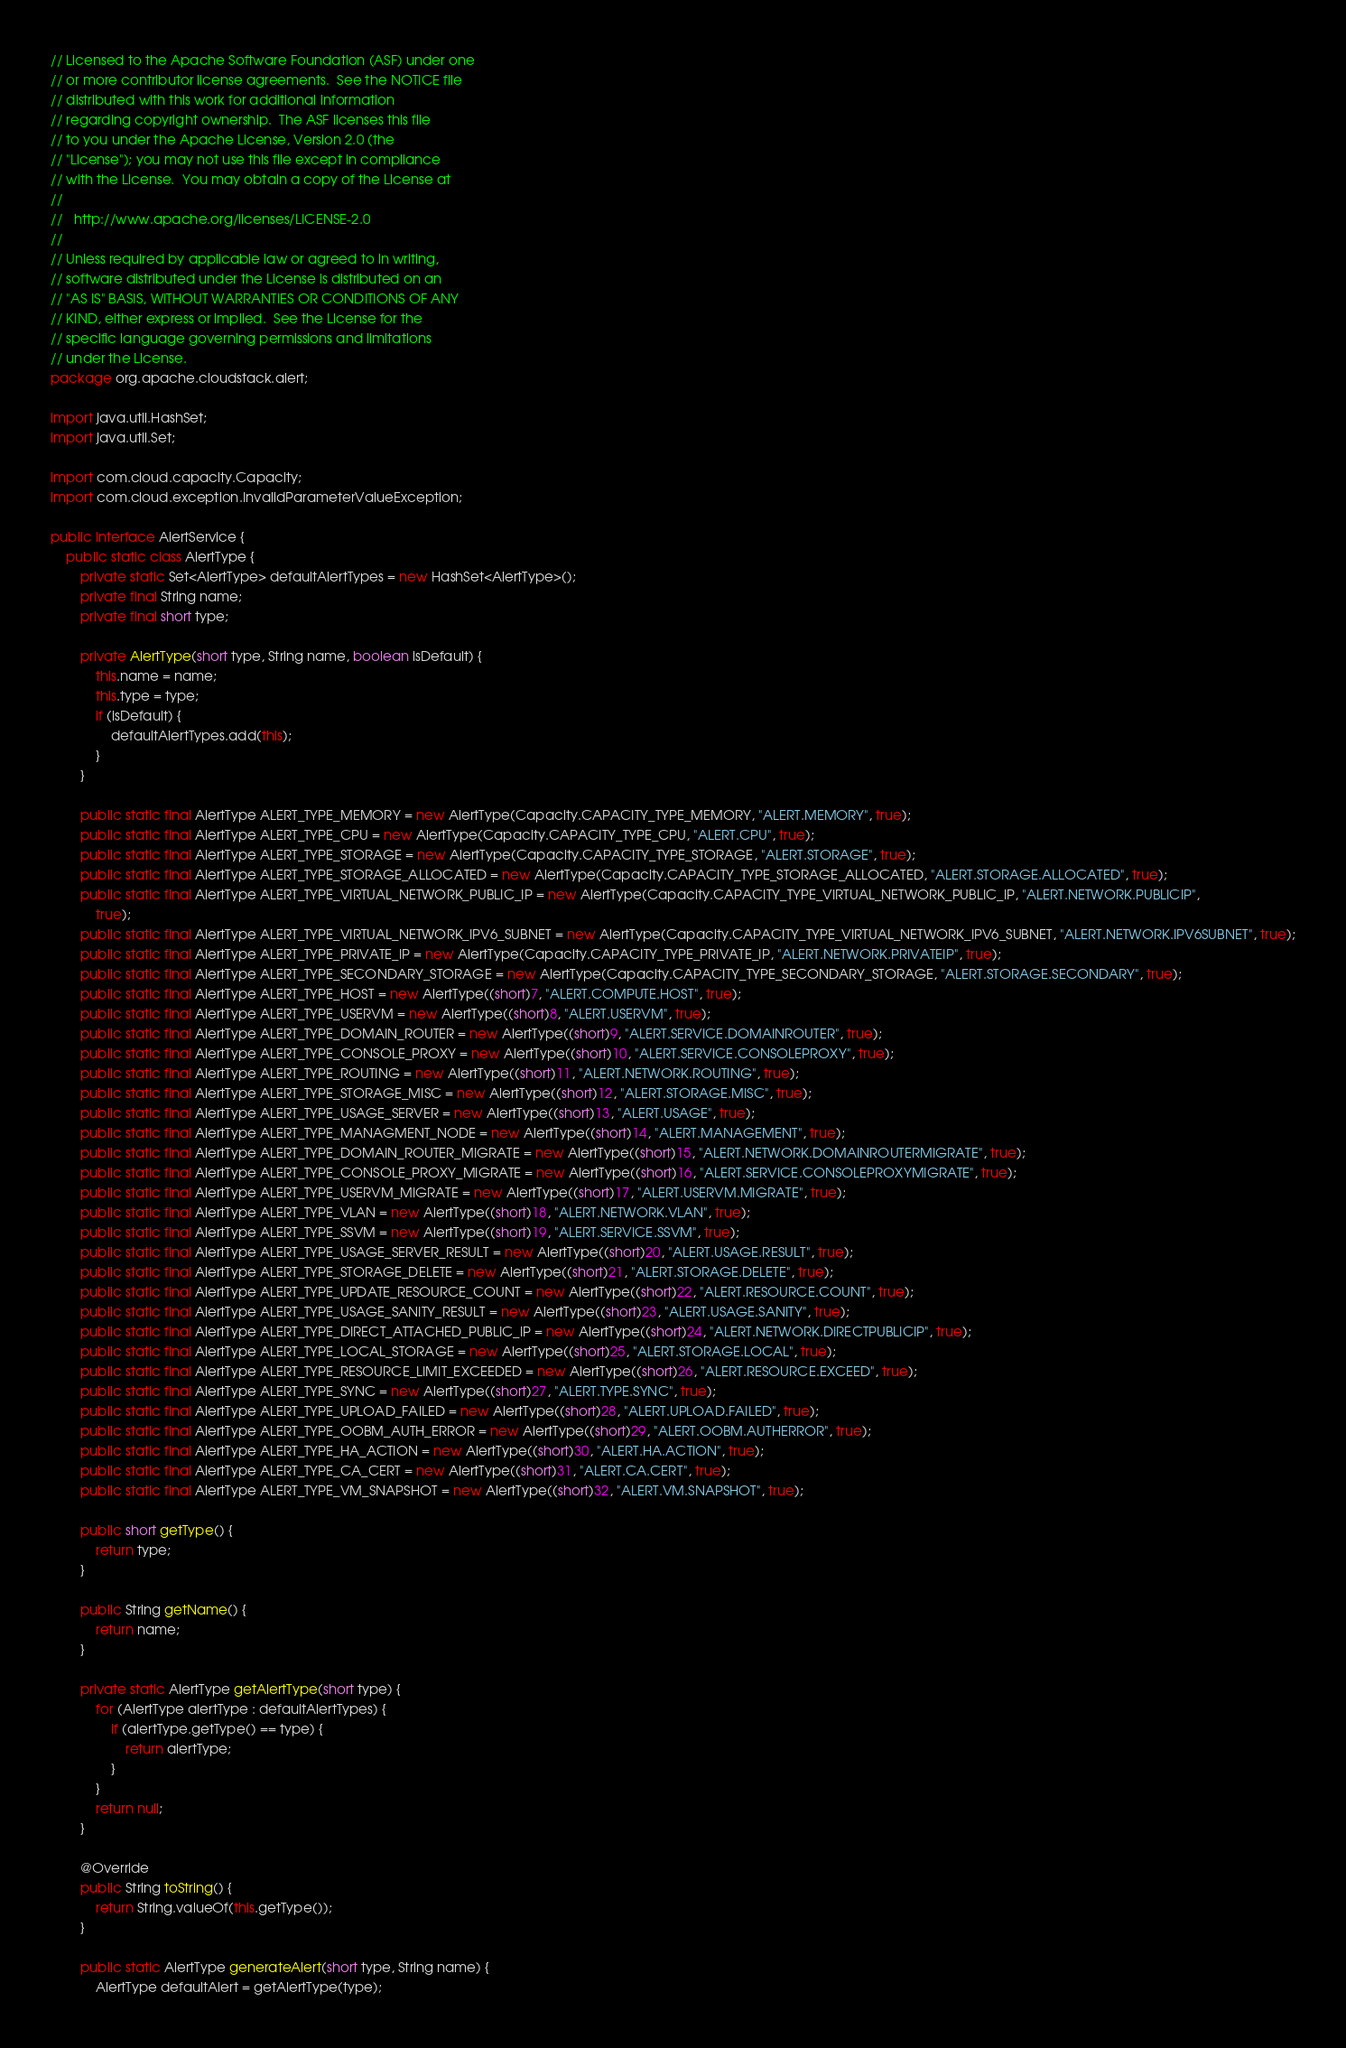Convert code to text. <code><loc_0><loc_0><loc_500><loc_500><_Java_>// Licensed to the Apache Software Foundation (ASF) under one
// or more contributor license agreements.  See the NOTICE file
// distributed with this work for additional information
// regarding copyright ownership.  The ASF licenses this file
// to you under the Apache License, Version 2.0 (the
// "License"); you may not use this file except in compliance
// with the License.  You may obtain a copy of the License at
//
//   http://www.apache.org/licenses/LICENSE-2.0
//
// Unless required by applicable law or agreed to in writing,
// software distributed under the License is distributed on an
// "AS IS" BASIS, WITHOUT WARRANTIES OR CONDITIONS OF ANY
// KIND, either express or implied.  See the License for the
// specific language governing permissions and limitations
// under the License.
package org.apache.cloudstack.alert;

import java.util.HashSet;
import java.util.Set;

import com.cloud.capacity.Capacity;
import com.cloud.exception.InvalidParameterValueException;

public interface AlertService {
    public static class AlertType {
        private static Set<AlertType> defaultAlertTypes = new HashSet<AlertType>();
        private final String name;
        private final short type;

        private AlertType(short type, String name, boolean isDefault) {
            this.name = name;
            this.type = type;
            if (isDefault) {
                defaultAlertTypes.add(this);
            }
        }

        public static final AlertType ALERT_TYPE_MEMORY = new AlertType(Capacity.CAPACITY_TYPE_MEMORY, "ALERT.MEMORY", true);
        public static final AlertType ALERT_TYPE_CPU = new AlertType(Capacity.CAPACITY_TYPE_CPU, "ALERT.CPU", true);
        public static final AlertType ALERT_TYPE_STORAGE = new AlertType(Capacity.CAPACITY_TYPE_STORAGE, "ALERT.STORAGE", true);
        public static final AlertType ALERT_TYPE_STORAGE_ALLOCATED = new AlertType(Capacity.CAPACITY_TYPE_STORAGE_ALLOCATED, "ALERT.STORAGE.ALLOCATED", true);
        public static final AlertType ALERT_TYPE_VIRTUAL_NETWORK_PUBLIC_IP = new AlertType(Capacity.CAPACITY_TYPE_VIRTUAL_NETWORK_PUBLIC_IP, "ALERT.NETWORK.PUBLICIP",
            true);
        public static final AlertType ALERT_TYPE_VIRTUAL_NETWORK_IPV6_SUBNET = new AlertType(Capacity.CAPACITY_TYPE_VIRTUAL_NETWORK_IPV6_SUBNET, "ALERT.NETWORK.IPV6SUBNET", true);
        public static final AlertType ALERT_TYPE_PRIVATE_IP = new AlertType(Capacity.CAPACITY_TYPE_PRIVATE_IP, "ALERT.NETWORK.PRIVATEIP", true);
        public static final AlertType ALERT_TYPE_SECONDARY_STORAGE = new AlertType(Capacity.CAPACITY_TYPE_SECONDARY_STORAGE, "ALERT.STORAGE.SECONDARY", true);
        public static final AlertType ALERT_TYPE_HOST = new AlertType((short)7, "ALERT.COMPUTE.HOST", true);
        public static final AlertType ALERT_TYPE_USERVM = new AlertType((short)8, "ALERT.USERVM", true);
        public static final AlertType ALERT_TYPE_DOMAIN_ROUTER = new AlertType((short)9, "ALERT.SERVICE.DOMAINROUTER", true);
        public static final AlertType ALERT_TYPE_CONSOLE_PROXY = new AlertType((short)10, "ALERT.SERVICE.CONSOLEPROXY", true);
        public static final AlertType ALERT_TYPE_ROUTING = new AlertType((short)11, "ALERT.NETWORK.ROUTING", true);
        public static final AlertType ALERT_TYPE_STORAGE_MISC = new AlertType((short)12, "ALERT.STORAGE.MISC", true);
        public static final AlertType ALERT_TYPE_USAGE_SERVER = new AlertType((short)13, "ALERT.USAGE", true);
        public static final AlertType ALERT_TYPE_MANAGMENT_NODE = new AlertType((short)14, "ALERT.MANAGEMENT", true);
        public static final AlertType ALERT_TYPE_DOMAIN_ROUTER_MIGRATE = new AlertType((short)15, "ALERT.NETWORK.DOMAINROUTERMIGRATE", true);
        public static final AlertType ALERT_TYPE_CONSOLE_PROXY_MIGRATE = new AlertType((short)16, "ALERT.SERVICE.CONSOLEPROXYMIGRATE", true);
        public static final AlertType ALERT_TYPE_USERVM_MIGRATE = new AlertType((short)17, "ALERT.USERVM.MIGRATE", true);
        public static final AlertType ALERT_TYPE_VLAN = new AlertType((short)18, "ALERT.NETWORK.VLAN", true);
        public static final AlertType ALERT_TYPE_SSVM = new AlertType((short)19, "ALERT.SERVICE.SSVM", true);
        public static final AlertType ALERT_TYPE_USAGE_SERVER_RESULT = new AlertType((short)20, "ALERT.USAGE.RESULT", true);
        public static final AlertType ALERT_TYPE_STORAGE_DELETE = new AlertType((short)21, "ALERT.STORAGE.DELETE", true);
        public static final AlertType ALERT_TYPE_UPDATE_RESOURCE_COUNT = new AlertType((short)22, "ALERT.RESOURCE.COUNT", true);
        public static final AlertType ALERT_TYPE_USAGE_SANITY_RESULT = new AlertType((short)23, "ALERT.USAGE.SANITY", true);
        public static final AlertType ALERT_TYPE_DIRECT_ATTACHED_PUBLIC_IP = new AlertType((short)24, "ALERT.NETWORK.DIRECTPUBLICIP", true);
        public static final AlertType ALERT_TYPE_LOCAL_STORAGE = new AlertType((short)25, "ALERT.STORAGE.LOCAL", true);
        public static final AlertType ALERT_TYPE_RESOURCE_LIMIT_EXCEEDED = new AlertType((short)26, "ALERT.RESOURCE.EXCEED", true);
        public static final AlertType ALERT_TYPE_SYNC = new AlertType((short)27, "ALERT.TYPE.SYNC", true);
        public static final AlertType ALERT_TYPE_UPLOAD_FAILED = new AlertType((short)28, "ALERT.UPLOAD.FAILED", true);
        public static final AlertType ALERT_TYPE_OOBM_AUTH_ERROR = new AlertType((short)29, "ALERT.OOBM.AUTHERROR", true);
        public static final AlertType ALERT_TYPE_HA_ACTION = new AlertType((short)30, "ALERT.HA.ACTION", true);
        public static final AlertType ALERT_TYPE_CA_CERT = new AlertType((short)31, "ALERT.CA.CERT", true);
        public static final AlertType ALERT_TYPE_VM_SNAPSHOT = new AlertType((short)32, "ALERT.VM.SNAPSHOT", true);

        public short getType() {
            return type;
        }

        public String getName() {
            return name;
        }

        private static AlertType getAlertType(short type) {
            for (AlertType alertType : defaultAlertTypes) {
                if (alertType.getType() == type) {
                    return alertType;
                }
            }
            return null;
        }

        @Override
        public String toString() {
            return String.valueOf(this.getType());
        }

        public static AlertType generateAlert(short type, String name) {
            AlertType defaultAlert = getAlertType(type);</code> 